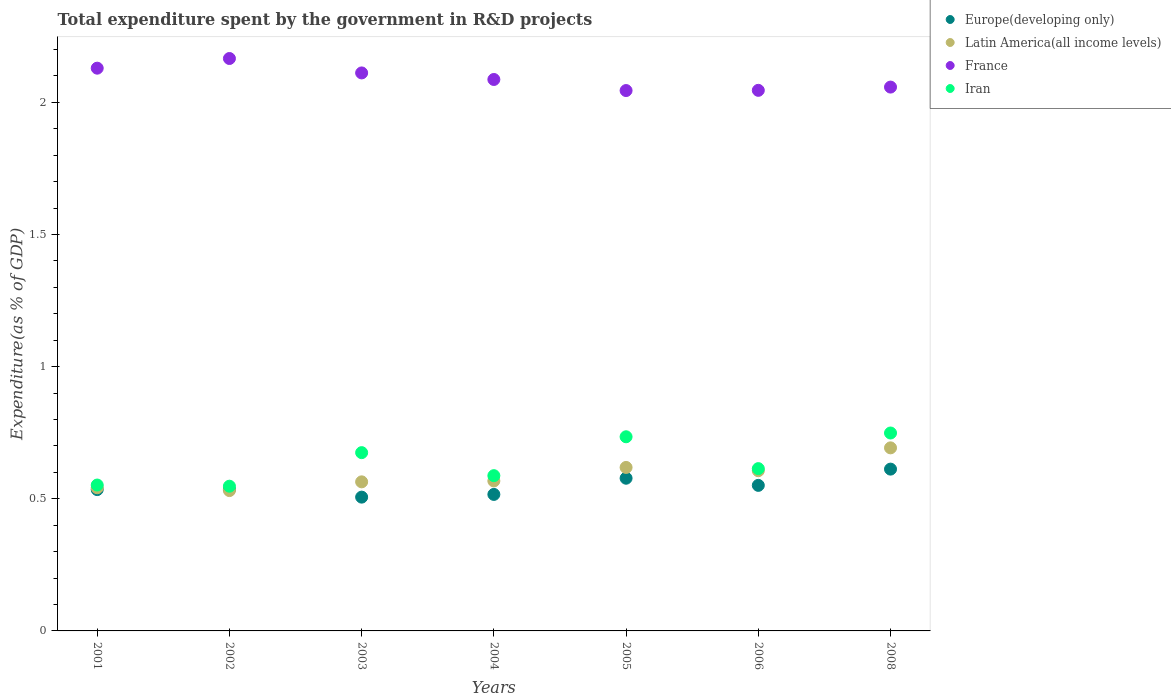What is the total expenditure spent by the government in R&D projects in France in 2002?
Your answer should be compact. 2.17. Across all years, what is the maximum total expenditure spent by the government in R&D projects in Latin America(all income levels)?
Offer a very short reply. 0.69. Across all years, what is the minimum total expenditure spent by the government in R&D projects in France?
Keep it short and to the point. 2.04. In which year was the total expenditure spent by the government in R&D projects in France minimum?
Give a very brief answer. 2005. What is the total total expenditure spent by the government in R&D projects in Europe(developing only) in the graph?
Give a very brief answer. 3.83. What is the difference between the total expenditure spent by the government in R&D projects in Europe(developing only) in 2005 and that in 2008?
Offer a terse response. -0.03. What is the difference between the total expenditure spent by the government in R&D projects in Latin America(all income levels) in 2002 and the total expenditure spent by the government in R&D projects in France in 2001?
Make the answer very short. -1.6. What is the average total expenditure spent by the government in R&D projects in Europe(developing only) per year?
Give a very brief answer. 0.55. In the year 2006, what is the difference between the total expenditure spent by the government in R&D projects in Europe(developing only) and total expenditure spent by the government in R&D projects in Iran?
Make the answer very short. -0.06. In how many years, is the total expenditure spent by the government in R&D projects in Europe(developing only) greater than 0.30000000000000004 %?
Offer a terse response. 7. What is the ratio of the total expenditure spent by the government in R&D projects in Latin America(all income levels) in 2002 to that in 2004?
Offer a very short reply. 0.94. Is the difference between the total expenditure spent by the government in R&D projects in Europe(developing only) in 2001 and 2003 greater than the difference between the total expenditure spent by the government in R&D projects in Iran in 2001 and 2003?
Your answer should be very brief. Yes. What is the difference between the highest and the second highest total expenditure spent by the government in R&D projects in Europe(developing only)?
Your answer should be compact. 0.03. What is the difference between the highest and the lowest total expenditure spent by the government in R&D projects in Iran?
Your response must be concise. 0.2. In how many years, is the total expenditure spent by the government in R&D projects in France greater than the average total expenditure spent by the government in R&D projects in France taken over all years?
Give a very brief answer. 3. Is it the case that in every year, the sum of the total expenditure spent by the government in R&D projects in France and total expenditure spent by the government in R&D projects in Iran  is greater than the sum of total expenditure spent by the government in R&D projects in Latin America(all income levels) and total expenditure spent by the government in R&D projects in Europe(developing only)?
Your response must be concise. Yes. Does the total expenditure spent by the government in R&D projects in Latin America(all income levels) monotonically increase over the years?
Your answer should be very brief. No. Is the total expenditure spent by the government in R&D projects in France strictly greater than the total expenditure spent by the government in R&D projects in Iran over the years?
Offer a terse response. Yes. Is the total expenditure spent by the government in R&D projects in Iran strictly less than the total expenditure spent by the government in R&D projects in France over the years?
Give a very brief answer. Yes. How many dotlines are there?
Keep it short and to the point. 4. How many years are there in the graph?
Give a very brief answer. 7. What is the difference between two consecutive major ticks on the Y-axis?
Ensure brevity in your answer.  0.5. Does the graph contain grids?
Make the answer very short. No. Where does the legend appear in the graph?
Give a very brief answer. Top right. How many legend labels are there?
Provide a succinct answer. 4. What is the title of the graph?
Ensure brevity in your answer.  Total expenditure spent by the government in R&D projects. Does "Mongolia" appear as one of the legend labels in the graph?
Give a very brief answer. No. What is the label or title of the Y-axis?
Your answer should be very brief. Expenditure(as % of GDP). What is the Expenditure(as % of GDP) in Europe(developing only) in 2001?
Your answer should be compact. 0.53. What is the Expenditure(as % of GDP) in Latin America(all income levels) in 2001?
Make the answer very short. 0.54. What is the Expenditure(as % of GDP) of France in 2001?
Provide a short and direct response. 2.13. What is the Expenditure(as % of GDP) in Iran in 2001?
Make the answer very short. 0.55. What is the Expenditure(as % of GDP) of Europe(developing only) in 2002?
Provide a short and direct response. 0.54. What is the Expenditure(as % of GDP) of Latin America(all income levels) in 2002?
Your response must be concise. 0.53. What is the Expenditure(as % of GDP) in France in 2002?
Keep it short and to the point. 2.17. What is the Expenditure(as % of GDP) in Iran in 2002?
Give a very brief answer. 0.55. What is the Expenditure(as % of GDP) in Europe(developing only) in 2003?
Make the answer very short. 0.51. What is the Expenditure(as % of GDP) in Latin America(all income levels) in 2003?
Your response must be concise. 0.56. What is the Expenditure(as % of GDP) of France in 2003?
Make the answer very short. 2.11. What is the Expenditure(as % of GDP) in Iran in 2003?
Give a very brief answer. 0.67. What is the Expenditure(as % of GDP) in Europe(developing only) in 2004?
Provide a short and direct response. 0.52. What is the Expenditure(as % of GDP) of Latin America(all income levels) in 2004?
Your response must be concise. 0.57. What is the Expenditure(as % of GDP) of France in 2004?
Provide a short and direct response. 2.09. What is the Expenditure(as % of GDP) in Iran in 2004?
Provide a succinct answer. 0.59. What is the Expenditure(as % of GDP) of Europe(developing only) in 2005?
Provide a succinct answer. 0.58. What is the Expenditure(as % of GDP) of Latin America(all income levels) in 2005?
Your response must be concise. 0.62. What is the Expenditure(as % of GDP) in France in 2005?
Ensure brevity in your answer.  2.04. What is the Expenditure(as % of GDP) in Iran in 2005?
Your response must be concise. 0.73. What is the Expenditure(as % of GDP) of Europe(developing only) in 2006?
Offer a terse response. 0.55. What is the Expenditure(as % of GDP) in Latin America(all income levels) in 2006?
Your answer should be very brief. 0.61. What is the Expenditure(as % of GDP) of France in 2006?
Provide a short and direct response. 2.05. What is the Expenditure(as % of GDP) of Iran in 2006?
Ensure brevity in your answer.  0.61. What is the Expenditure(as % of GDP) of Europe(developing only) in 2008?
Your response must be concise. 0.61. What is the Expenditure(as % of GDP) in Latin America(all income levels) in 2008?
Provide a succinct answer. 0.69. What is the Expenditure(as % of GDP) in France in 2008?
Your answer should be compact. 2.06. What is the Expenditure(as % of GDP) in Iran in 2008?
Your answer should be very brief. 0.75. Across all years, what is the maximum Expenditure(as % of GDP) of Europe(developing only)?
Your response must be concise. 0.61. Across all years, what is the maximum Expenditure(as % of GDP) of Latin America(all income levels)?
Your answer should be compact. 0.69. Across all years, what is the maximum Expenditure(as % of GDP) in France?
Provide a succinct answer. 2.17. Across all years, what is the maximum Expenditure(as % of GDP) of Iran?
Your answer should be compact. 0.75. Across all years, what is the minimum Expenditure(as % of GDP) of Europe(developing only)?
Your answer should be very brief. 0.51. Across all years, what is the minimum Expenditure(as % of GDP) in Latin America(all income levels)?
Your answer should be very brief. 0.53. Across all years, what is the minimum Expenditure(as % of GDP) of France?
Keep it short and to the point. 2.04. Across all years, what is the minimum Expenditure(as % of GDP) in Iran?
Ensure brevity in your answer.  0.55. What is the total Expenditure(as % of GDP) of Europe(developing only) in the graph?
Provide a short and direct response. 3.83. What is the total Expenditure(as % of GDP) of Latin America(all income levels) in the graph?
Your response must be concise. 4.12. What is the total Expenditure(as % of GDP) of France in the graph?
Offer a very short reply. 14.64. What is the total Expenditure(as % of GDP) in Iran in the graph?
Keep it short and to the point. 4.46. What is the difference between the Expenditure(as % of GDP) of Europe(developing only) in 2001 and that in 2002?
Provide a succinct answer. -0. What is the difference between the Expenditure(as % of GDP) of Latin America(all income levels) in 2001 and that in 2002?
Ensure brevity in your answer.  0.01. What is the difference between the Expenditure(as % of GDP) of France in 2001 and that in 2002?
Keep it short and to the point. -0.04. What is the difference between the Expenditure(as % of GDP) in Iran in 2001 and that in 2002?
Ensure brevity in your answer.  0. What is the difference between the Expenditure(as % of GDP) in Europe(developing only) in 2001 and that in 2003?
Offer a terse response. 0.03. What is the difference between the Expenditure(as % of GDP) in Latin America(all income levels) in 2001 and that in 2003?
Your response must be concise. -0.02. What is the difference between the Expenditure(as % of GDP) of France in 2001 and that in 2003?
Give a very brief answer. 0.02. What is the difference between the Expenditure(as % of GDP) of Iran in 2001 and that in 2003?
Your answer should be compact. -0.12. What is the difference between the Expenditure(as % of GDP) of Europe(developing only) in 2001 and that in 2004?
Offer a terse response. 0.02. What is the difference between the Expenditure(as % of GDP) of Latin America(all income levels) in 2001 and that in 2004?
Offer a very short reply. -0.03. What is the difference between the Expenditure(as % of GDP) in France in 2001 and that in 2004?
Keep it short and to the point. 0.04. What is the difference between the Expenditure(as % of GDP) of Iran in 2001 and that in 2004?
Provide a succinct answer. -0.04. What is the difference between the Expenditure(as % of GDP) of Europe(developing only) in 2001 and that in 2005?
Offer a terse response. -0.04. What is the difference between the Expenditure(as % of GDP) of Latin America(all income levels) in 2001 and that in 2005?
Make the answer very short. -0.08. What is the difference between the Expenditure(as % of GDP) in France in 2001 and that in 2005?
Keep it short and to the point. 0.08. What is the difference between the Expenditure(as % of GDP) of Iran in 2001 and that in 2005?
Ensure brevity in your answer.  -0.18. What is the difference between the Expenditure(as % of GDP) in Europe(developing only) in 2001 and that in 2006?
Offer a terse response. -0.02. What is the difference between the Expenditure(as % of GDP) in Latin America(all income levels) in 2001 and that in 2006?
Your answer should be compact. -0.06. What is the difference between the Expenditure(as % of GDP) of France in 2001 and that in 2006?
Make the answer very short. 0.08. What is the difference between the Expenditure(as % of GDP) of Iran in 2001 and that in 2006?
Your answer should be compact. -0.06. What is the difference between the Expenditure(as % of GDP) of Europe(developing only) in 2001 and that in 2008?
Your answer should be compact. -0.08. What is the difference between the Expenditure(as % of GDP) in Latin America(all income levels) in 2001 and that in 2008?
Your answer should be compact. -0.15. What is the difference between the Expenditure(as % of GDP) in France in 2001 and that in 2008?
Your response must be concise. 0.07. What is the difference between the Expenditure(as % of GDP) in Iran in 2001 and that in 2008?
Make the answer very short. -0.2. What is the difference between the Expenditure(as % of GDP) of Europe(developing only) in 2002 and that in 2003?
Offer a terse response. 0.03. What is the difference between the Expenditure(as % of GDP) of Latin America(all income levels) in 2002 and that in 2003?
Ensure brevity in your answer.  -0.03. What is the difference between the Expenditure(as % of GDP) in France in 2002 and that in 2003?
Make the answer very short. 0.05. What is the difference between the Expenditure(as % of GDP) of Iran in 2002 and that in 2003?
Give a very brief answer. -0.13. What is the difference between the Expenditure(as % of GDP) of Europe(developing only) in 2002 and that in 2004?
Your answer should be very brief. 0.02. What is the difference between the Expenditure(as % of GDP) in Latin America(all income levels) in 2002 and that in 2004?
Your answer should be very brief. -0.04. What is the difference between the Expenditure(as % of GDP) in France in 2002 and that in 2004?
Provide a short and direct response. 0.08. What is the difference between the Expenditure(as % of GDP) in Iran in 2002 and that in 2004?
Make the answer very short. -0.04. What is the difference between the Expenditure(as % of GDP) in Europe(developing only) in 2002 and that in 2005?
Ensure brevity in your answer.  -0.04. What is the difference between the Expenditure(as % of GDP) in Latin America(all income levels) in 2002 and that in 2005?
Your answer should be compact. -0.09. What is the difference between the Expenditure(as % of GDP) in France in 2002 and that in 2005?
Your answer should be compact. 0.12. What is the difference between the Expenditure(as % of GDP) of Iran in 2002 and that in 2005?
Give a very brief answer. -0.19. What is the difference between the Expenditure(as % of GDP) in Europe(developing only) in 2002 and that in 2006?
Give a very brief answer. -0.02. What is the difference between the Expenditure(as % of GDP) in Latin America(all income levels) in 2002 and that in 2006?
Your answer should be very brief. -0.08. What is the difference between the Expenditure(as % of GDP) in France in 2002 and that in 2006?
Offer a terse response. 0.12. What is the difference between the Expenditure(as % of GDP) of Iran in 2002 and that in 2006?
Keep it short and to the point. -0.07. What is the difference between the Expenditure(as % of GDP) in Europe(developing only) in 2002 and that in 2008?
Your answer should be compact. -0.08. What is the difference between the Expenditure(as % of GDP) of Latin America(all income levels) in 2002 and that in 2008?
Make the answer very short. -0.16. What is the difference between the Expenditure(as % of GDP) in France in 2002 and that in 2008?
Provide a short and direct response. 0.11. What is the difference between the Expenditure(as % of GDP) of Iran in 2002 and that in 2008?
Provide a short and direct response. -0.2. What is the difference between the Expenditure(as % of GDP) in Europe(developing only) in 2003 and that in 2004?
Your response must be concise. -0.01. What is the difference between the Expenditure(as % of GDP) in Latin America(all income levels) in 2003 and that in 2004?
Your answer should be very brief. -0. What is the difference between the Expenditure(as % of GDP) of France in 2003 and that in 2004?
Provide a succinct answer. 0.02. What is the difference between the Expenditure(as % of GDP) of Iran in 2003 and that in 2004?
Your response must be concise. 0.09. What is the difference between the Expenditure(as % of GDP) of Europe(developing only) in 2003 and that in 2005?
Your response must be concise. -0.07. What is the difference between the Expenditure(as % of GDP) in Latin America(all income levels) in 2003 and that in 2005?
Your answer should be very brief. -0.05. What is the difference between the Expenditure(as % of GDP) of France in 2003 and that in 2005?
Offer a terse response. 0.07. What is the difference between the Expenditure(as % of GDP) in Iran in 2003 and that in 2005?
Make the answer very short. -0.06. What is the difference between the Expenditure(as % of GDP) in Europe(developing only) in 2003 and that in 2006?
Your answer should be very brief. -0.04. What is the difference between the Expenditure(as % of GDP) in Latin America(all income levels) in 2003 and that in 2006?
Your answer should be compact. -0.04. What is the difference between the Expenditure(as % of GDP) in France in 2003 and that in 2006?
Offer a very short reply. 0.07. What is the difference between the Expenditure(as % of GDP) of Iran in 2003 and that in 2006?
Offer a very short reply. 0.06. What is the difference between the Expenditure(as % of GDP) in Europe(developing only) in 2003 and that in 2008?
Offer a terse response. -0.11. What is the difference between the Expenditure(as % of GDP) in Latin America(all income levels) in 2003 and that in 2008?
Your response must be concise. -0.13. What is the difference between the Expenditure(as % of GDP) in France in 2003 and that in 2008?
Provide a short and direct response. 0.05. What is the difference between the Expenditure(as % of GDP) of Iran in 2003 and that in 2008?
Provide a succinct answer. -0.07. What is the difference between the Expenditure(as % of GDP) of Europe(developing only) in 2004 and that in 2005?
Give a very brief answer. -0.06. What is the difference between the Expenditure(as % of GDP) in Latin America(all income levels) in 2004 and that in 2005?
Your answer should be compact. -0.05. What is the difference between the Expenditure(as % of GDP) of France in 2004 and that in 2005?
Your response must be concise. 0.04. What is the difference between the Expenditure(as % of GDP) of Iran in 2004 and that in 2005?
Offer a terse response. -0.15. What is the difference between the Expenditure(as % of GDP) in Europe(developing only) in 2004 and that in 2006?
Your answer should be very brief. -0.03. What is the difference between the Expenditure(as % of GDP) in Latin America(all income levels) in 2004 and that in 2006?
Give a very brief answer. -0.04. What is the difference between the Expenditure(as % of GDP) of France in 2004 and that in 2006?
Ensure brevity in your answer.  0.04. What is the difference between the Expenditure(as % of GDP) of Iran in 2004 and that in 2006?
Provide a succinct answer. -0.03. What is the difference between the Expenditure(as % of GDP) in Europe(developing only) in 2004 and that in 2008?
Provide a succinct answer. -0.1. What is the difference between the Expenditure(as % of GDP) of Latin America(all income levels) in 2004 and that in 2008?
Provide a short and direct response. -0.13. What is the difference between the Expenditure(as % of GDP) of France in 2004 and that in 2008?
Offer a very short reply. 0.03. What is the difference between the Expenditure(as % of GDP) of Iran in 2004 and that in 2008?
Keep it short and to the point. -0.16. What is the difference between the Expenditure(as % of GDP) of Europe(developing only) in 2005 and that in 2006?
Your answer should be compact. 0.03. What is the difference between the Expenditure(as % of GDP) of Latin America(all income levels) in 2005 and that in 2006?
Your response must be concise. 0.01. What is the difference between the Expenditure(as % of GDP) in France in 2005 and that in 2006?
Offer a very short reply. -0. What is the difference between the Expenditure(as % of GDP) of Iran in 2005 and that in 2006?
Make the answer very short. 0.12. What is the difference between the Expenditure(as % of GDP) in Europe(developing only) in 2005 and that in 2008?
Offer a terse response. -0.03. What is the difference between the Expenditure(as % of GDP) of Latin America(all income levels) in 2005 and that in 2008?
Your answer should be compact. -0.07. What is the difference between the Expenditure(as % of GDP) of France in 2005 and that in 2008?
Your response must be concise. -0.01. What is the difference between the Expenditure(as % of GDP) of Iran in 2005 and that in 2008?
Your answer should be compact. -0.01. What is the difference between the Expenditure(as % of GDP) in Europe(developing only) in 2006 and that in 2008?
Your answer should be very brief. -0.06. What is the difference between the Expenditure(as % of GDP) in Latin America(all income levels) in 2006 and that in 2008?
Provide a succinct answer. -0.09. What is the difference between the Expenditure(as % of GDP) in France in 2006 and that in 2008?
Give a very brief answer. -0.01. What is the difference between the Expenditure(as % of GDP) of Iran in 2006 and that in 2008?
Offer a terse response. -0.13. What is the difference between the Expenditure(as % of GDP) of Europe(developing only) in 2001 and the Expenditure(as % of GDP) of Latin America(all income levels) in 2002?
Offer a terse response. 0. What is the difference between the Expenditure(as % of GDP) in Europe(developing only) in 2001 and the Expenditure(as % of GDP) in France in 2002?
Your answer should be very brief. -1.63. What is the difference between the Expenditure(as % of GDP) of Europe(developing only) in 2001 and the Expenditure(as % of GDP) of Iran in 2002?
Offer a very short reply. -0.01. What is the difference between the Expenditure(as % of GDP) of Latin America(all income levels) in 2001 and the Expenditure(as % of GDP) of France in 2002?
Your response must be concise. -1.62. What is the difference between the Expenditure(as % of GDP) in Latin America(all income levels) in 2001 and the Expenditure(as % of GDP) in Iran in 2002?
Keep it short and to the point. -0.01. What is the difference between the Expenditure(as % of GDP) of France in 2001 and the Expenditure(as % of GDP) of Iran in 2002?
Give a very brief answer. 1.58. What is the difference between the Expenditure(as % of GDP) in Europe(developing only) in 2001 and the Expenditure(as % of GDP) in Latin America(all income levels) in 2003?
Your response must be concise. -0.03. What is the difference between the Expenditure(as % of GDP) of Europe(developing only) in 2001 and the Expenditure(as % of GDP) of France in 2003?
Keep it short and to the point. -1.58. What is the difference between the Expenditure(as % of GDP) of Europe(developing only) in 2001 and the Expenditure(as % of GDP) of Iran in 2003?
Your answer should be very brief. -0.14. What is the difference between the Expenditure(as % of GDP) in Latin America(all income levels) in 2001 and the Expenditure(as % of GDP) in France in 2003?
Provide a short and direct response. -1.57. What is the difference between the Expenditure(as % of GDP) in Latin America(all income levels) in 2001 and the Expenditure(as % of GDP) in Iran in 2003?
Your answer should be very brief. -0.13. What is the difference between the Expenditure(as % of GDP) in France in 2001 and the Expenditure(as % of GDP) in Iran in 2003?
Ensure brevity in your answer.  1.45. What is the difference between the Expenditure(as % of GDP) in Europe(developing only) in 2001 and the Expenditure(as % of GDP) in Latin America(all income levels) in 2004?
Provide a short and direct response. -0.03. What is the difference between the Expenditure(as % of GDP) in Europe(developing only) in 2001 and the Expenditure(as % of GDP) in France in 2004?
Your answer should be very brief. -1.55. What is the difference between the Expenditure(as % of GDP) of Europe(developing only) in 2001 and the Expenditure(as % of GDP) of Iran in 2004?
Keep it short and to the point. -0.05. What is the difference between the Expenditure(as % of GDP) of Latin America(all income levels) in 2001 and the Expenditure(as % of GDP) of France in 2004?
Make the answer very short. -1.54. What is the difference between the Expenditure(as % of GDP) of Latin America(all income levels) in 2001 and the Expenditure(as % of GDP) of Iran in 2004?
Make the answer very short. -0.05. What is the difference between the Expenditure(as % of GDP) of France in 2001 and the Expenditure(as % of GDP) of Iran in 2004?
Provide a short and direct response. 1.54. What is the difference between the Expenditure(as % of GDP) of Europe(developing only) in 2001 and the Expenditure(as % of GDP) of Latin America(all income levels) in 2005?
Offer a very short reply. -0.08. What is the difference between the Expenditure(as % of GDP) of Europe(developing only) in 2001 and the Expenditure(as % of GDP) of France in 2005?
Your answer should be compact. -1.51. What is the difference between the Expenditure(as % of GDP) in Europe(developing only) in 2001 and the Expenditure(as % of GDP) in Iran in 2005?
Offer a terse response. -0.2. What is the difference between the Expenditure(as % of GDP) in Latin America(all income levels) in 2001 and the Expenditure(as % of GDP) in France in 2005?
Provide a succinct answer. -1.5. What is the difference between the Expenditure(as % of GDP) of Latin America(all income levels) in 2001 and the Expenditure(as % of GDP) of Iran in 2005?
Give a very brief answer. -0.19. What is the difference between the Expenditure(as % of GDP) in France in 2001 and the Expenditure(as % of GDP) in Iran in 2005?
Provide a succinct answer. 1.39. What is the difference between the Expenditure(as % of GDP) of Europe(developing only) in 2001 and the Expenditure(as % of GDP) of Latin America(all income levels) in 2006?
Make the answer very short. -0.07. What is the difference between the Expenditure(as % of GDP) in Europe(developing only) in 2001 and the Expenditure(as % of GDP) in France in 2006?
Your answer should be compact. -1.51. What is the difference between the Expenditure(as % of GDP) in Europe(developing only) in 2001 and the Expenditure(as % of GDP) in Iran in 2006?
Your answer should be compact. -0.08. What is the difference between the Expenditure(as % of GDP) in Latin America(all income levels) in 2001 and the Expenditure(as % of GDP) in France in 2006?
Your response must be concise. -1.5. What is the difference between the Expenditure(as % of GDP) in Latin America(all income levels) in 2001 and the Expenditure(as % of GDP) in Iran in 2006?
Keep it short and to the point. -0.07. What is the difference between the Expenditure(as % of GDP) of France in 2001 and the Expenditure(as % of GDP) of Iran in 2006?
Offer a very short reply. 1.52. What is the difference between the Expenditure(as % of GDP) in Europe(developing only) in 2001 and the Expenditure(as % of GDP) in Latin America(all income levels) in 2008?
Provide a succinct answer. -0.16. What is the difference between the Expenditure(as % of GDP) of Europe(developing only) in 2001 and the Expenditure(as % of GDP) of France in 2008?
Your response must be concise. -1.52. What is the difference between the Expenditure(as % of GDP) in Europe(developing only) in 2001 and the Expenditure(as % of GDP) in Iran in 2008?
Offer a terse response. -0.21. What is the difference between the Expenditure(as % of GDP) in Latin America(all income levels) in 2001 and the Expenditure(as % of GDP) in France in 2008?
Ensure brevity in your answer.  -1.52. What is the difference between the Expenditure(as % of GDP) of Latin America(all income levels) in 2001 and the Expenditure(as % of GDP) of Iran in 2008?
Your answer should be compact. -0.21. What is the difference between the Expenditure(as % of GDP) in France in 2001 and the Expenditure(as % of GDP) in Iran in 2008?
Provide a short and direct response. 1.38. What is the difference between the Expenditure(as % of GDP) of Europe(developing only) in 2002 and the Expenditure(as % of GDP) of Latin America(all income levels) in 2003?
Your response must be concise. -0.03. What is the difference between the Expenditure(as % of GDP) in Europe(developing only) in 2002 and the Expenditure(as % of GDP) in France in 2003?
Your response must be concise. -1.58. What is the difference between the Expenditure(as % of GDP) of Europe(developing only) in 2002 and the Expenditure(as % of GDP) of Iran in 2003?
Make the answer very short. -0.14. What is the difference between the Expenditure(as % of GDP) in Latin America(all income levels) in 2002 and the Expenditure(as % of GDP) in France in 2003?
Provide a succinct answer. -1.58. What is the difference between the Expenditure(as % of GDP) in Latin America(all income levels) in 2002 and the Expenditure(as % of GDP) in Iran in 2003?
Provide a succinct answer. -0.14. What is the difference between the Expenditure(as % of GDP) of France in 2002 and the Expenditure(as % of GDP) of Iran in 2003?
Provide a succinct answer. 1.49. What is the difference between the Expenditure(as % of GDP) in Europe(developing only) in 2002 and the Expenditure(as % of GDP) in Latin America(all income levels) in 2004?
Your answer should be very brief. -0.03. What is the difference between the Expenditure(as % of GDP) of Europe(developing only) in 2002 and the Expenditure(as % of GDP) of France in 2004?
Make the answer very short. -1.55. What is the difference between the Expenditure(as % of GDP) in Europe(developing only) in 2002 and the Expenditure(as % of GDP) in Iran in 2004?
Keep it short and to the point. -0.05. What is the difference between the Expenditure(as % of GDP) in Latin America(all income levels) in 2002 and the Expenditure(as % of GDP) in France in 2004?
Your answer should be compact. -1.56. What is the difference between the Expenditure(as % of GDP) of Latin America(all income levels) in 2002 and the Expenditure(as % of GDP) of Iran in 2004?
Your response must be concise. -0.06. What is the difference between the Expenditure(as % of GDP) of France in 2002 and the Expenditure(as % of GDP) of Iran in 2004?
Your response must be concise. 1.58. What is the difference between the Expenditure(as % of GDP) in Europe(developing only) in 2002 and the Expenditure(as % of GDP) in Latin America(all income levels) in 2005?
Your answer should be compact. -0.08. What is the difference between the Expenditure(as % of GDP) in Europe(developing only) in 2002 and the Expenditure(as % of GDP) in France in 2005?
Provide a short and direct response. -1.51. What is the difference between the Expenditure(as % of GDP) of Europe(developing only) in 2002 and the Expenditure(as % of GDP) of Iran in 2005?
Your answer should be compact. -0.2. What is the difference between the Expenditure(as % of GDP) in Latin America(all income levels) in 2002 and the Expenditure(as % of GDP) in France in 2005?
Ensure brevity in your answer.  -1.51. What is the difference between the Expenditure(as % of GDP) in Latin America(all income levels) in 2002 and the Expenditure(as % of GDP) in Iran in 2005?
Keep it short and to the point. -0.2. What is the difference between the Expenditure(as % of GDP) of France in 2002 and the Expenditure(as % of GDP) of Iran in 2005?
Your response must be concise. 1.43. What is the difference between the Expenditure(as % of GDP) of Europe(developing only) in 2002 and the Expenditure(as % of GDP) of Latin America(all income levels) in 2006?
Offer a very short reply. -0.07. What is the difference between the Expenditure(as % of GDP) in Europe(developing only) in 2002 and the Expenditure(as % of GDP) in France in 2006?
Make the answer very short. -1.51. What is the difference between the Expenditure(as % of GDP) of Europe(developing only) in 2002 and the Expenditure(as % of GDP) of Iran in 2006?
Make the answer very short. -0.08. What is the difference between the Expenditure(as % of GDP) in Latin America(all income levels) in 2002 and the Expenditure(as % of GDP) in France in 2006?
Give a very brief answer. -1.51. What is the difference between the Expenditure(as % of GDP) of Latin America(all income levels) in 2002 and the Expenditure(as % of GDP) of Iran in 2006?
Offer a very short reply. -0.08. What is the difference between the Expenditure(as % of GDP) in France in 2002 and the Expenditure(as % of GDP) in Iran in 2006?
Ensure brevity in your answer.  1.55. What is the difference between the Expenditure(as % of GDP) of Europe(developing only) in 2002 and the Expenditure(as % of GDP) of Latin America(all income levels) in 2008?
Provide a short and direct response. -0.16. What is the difference between the Expenditure(as % of GDP) of Europe(developing only) in 2002 and the Expenditure(as % of GDP) of France in 2008?
Offer a very short reply. -1.52. What is the difference between the Expenditure(as % of GDP) in Europe(developing only) in 2002 and the Expenditure(as % of GDP) in Iran in 2008?
Your answer should be very brief. -0.21. What is the difference between the Expenditure(as % of GDP) in Latin America(all income levels) in 2002 and the Expenditure(as % of GDP) in France in 2008?
Make the answer very short. -1.53. What is the difference between the Expenditure(as % of GDP) of Latin America(all income levels) in 2002 and the Expenditure(as % of GDP) of Iran in 2008?
Offer a terse response. -0.22. What is the difference between the Expenditure(as % of GDP) of France in 2002 and the Expenditure(as % of GDP) of Iran in 2008?
Provide a short and direct response. 1.42. What is the difference between the Expenditure(as % of GDP) in Europe(developing only) in 2003 and the Expenditure(as % of GDP) in Latin America(all income levels) in 2004?
Your answer should be compact. -0.06. What is the difference between the Expenditure(as % of GDP) of Europe(developing only) in 2003 and the Expenditure(as % of GDP) of France in 2004?
Your answer should be compact. -1.58. What is the difference between the Expenditure(as % of GDP) in Europe(developing only) in 2003 and the Expenditure(as % of GDP) in Iran in 2004?
Your response must be concise. -0.08. What is the difference between the Expenditure(as % of GDP) of Latin America(all income levels) in 2003 and the Expenditure(as % of GDP) of France in 2004?
Give a very brief answer. -1.52. What is the difference between the Expenditure(as % of GDP) in Latin America(all income levels) in 2003 and the Expenditure(as % of GDP) in Iran in 2004?
Offer a very short reply. -0.02. What is the difference between the Expenditure(as % of GDP) in France in 2003 and the Expenditure(as % of GDP) in Iran in 2004?
Offer a very short reply. 1.52. What is the difference between the Expenditure(as % of GDP) in Europe(developing only) in 2003 and the Expenditure(as % of GDP) in Latin America(all income levels) in 2005?
Your answer should be very brief. -0.11. What is the difference between the Expenditure(as % of GDP) in Europe(developing only) in 2003 and the Expenditure(as % of GDP) in France in 2005?
Give a very brief answer. -1.54. What is the difference between the Expenditure(as % of GDP) of Europe(developing only) in 2003 and the Expenditure(as % of GDP) of Iran in 2005?
Provide a short and direct response. -0.23. What is the difference between the Expenditure(as % of GDP) of Latin America(all income levels) in 2003 and the Expenditure(as % of GDP) of France in 2005?
Offer a very short reply. -1.48. What is the difference between the Expenditure(as % of GDP) in Latin America(all income levels) in 2003 and the Expenditure(as % of GDP) in Iran in 2005?
Your answer should be very brief. -0.17. What is the difference between the Expenditure(as % of GDP) of France in 2003 and the Expenditure(as % of GDP) of Iran in 2005?
Provide a short and direct response. 1.38. What is the difference between the Expenditure(as % of GDP) in Europe(developing only) in 2003 and the Expenditure(as % of GDP) in Latin America(all income levels) in 2006?
Provide a short and direct response. -0.1. What is the difference between the Expenditure(as % of GDP) of Europe(developing only) in 2003 and the Expenditure(as % of GDP) of France in 2006?
Provide a short and direct response. -1.54. What is the difference between the Expenditure(as % of GDP) of Europe(developing only) in 2003 and the Expenditure(as % of GDP) of Iran in 2006?
Offer a terse response. -0.11. What is the difference between the Expenditure(as % of GDP) of Latin America(all income levels) in 2003 and the Expenditure(as % of GDP) of France in 2006?
Give a very brief answer. -1.48. What is the difference between the Expenditure(as % of GDP) in France in 2003 and the Expenditure(as % of GDP) in Iran in 2006?
Provide a short and direct response. 1.5. What is the difference between the Expenditure(as % of GDP) of Europe(developing only) in 2003 and the Expenditure(as % of GDP) of Latin America(all income levels) in 2008?
Your response must be concise. -0.19. What is the difference between the Expenditure(as % of GDP) of Europe(developing only) in 2003 and the Expenditure(as % of GDP) of France in 2008?
Ensure brevity in your answer.  -1.55. What is the difference between the Expenditure(as % of GDP) of Europe(developing only) in 2003 and the Expenditure(as % of GDP) of Iran in 2008?
Your answer should be compact. -0.24. What is the difference between the Expenditure(as % of GDP) of Latin America(all income levels) in 2003 and the Expenditure(as % of GDP) of France in 2008?
Offer a very short reply. -1.49. What is the difference between the Expenditure(as % of GDP) of Latin America(all income levels) in 2003 and the Expenditure(as % of GDP) of Iran in 2008?
Your answer should be very brief. -0.18. What is the difference between the Expenditure(as % of GDP) of France in 2003 and the Expenditure(as % of GDP) of Iran in 2008?
Give a very brief answer. 1.36. What is the difference between the Expenditure(as % of GDP) of Europe(developing only) in 2004 and the Expenditure(as % of GDP) of Latin America(all income levels) in 2005?
Make the answer very short. -0.1. What is the difference between the Expenditure(as % of GDP) in Europe(developing only) in 2004 and the Expenditure(as % of GDP) in France in 2005?
Provide a succinct answer. -1.53. What is the difference between the Expenditure(as % of GDP) of Europe(developing only) in 2004 and the Expenditure(as % of GDP) of Iran in 2005?
Provide a succinct answer. -0.22. What is the difference between the Expenditure(as % of GDP) in Latin America(all income levels) in 2004 and the Expenditure(as % of GDP) in France in 2005?
Offer a terse response. -1.48. What is the difference between the Expenditure(as % of GDP) in Latin America(all income levels) in 2004 and the Expenditure(as % of GDP) in Iran in 2005?
Offer a terse response. -0.17. What is the difference between the Expenditure(as % of GDP) of France in 2004 and the Expenditure(as % of GDP) of Iran in 2005?
Your answer should be very brief. 1.35. What is the difference between the Expenditure(as % of GDP) of Europe(developing only) in 2004 and the Expenditure(as % of GDP) of Latin America(all income levels) in 2006?
Ensure brevity in your answer.  -0.09. What is the difference between the Expenditure(as % of GDP) of Europe(developing only) in 2004 and the Expenditure(as % of GDP) of France in 2006?
Give a very brief answer. -1.53. What is the difference between the Expenditure(as % of GDP) in Europe(developing only) in 2004 and the Expenditure(as % of GDP) in Iran in 2006?
Offer a very short reply. -0.1. What is the difference between the Expenditure(as % of GDP) of Latin America(all income levels) in 2004 and the Expenditure(as % of GDP) of France in 2006?
Give a very brief answer. -1.48. What is the difference between the Expenditure(as % of GDP) in Latin America(all income levels) in 2004 and the Expenditure(as % of GDP) in Iran in 2006?
Provide a succinct answer. -0.05. What is the difference between the Expenditure(as % of GDP) of France in 2004 and the Expenditure(as % of GDP) of Iran in 2006?
Provide a succinct answer. 1.47. What is the difference between the Expenditure(as % of GDP) of Europe(developing only) in 2004 and the Expenditure(as % of GDP) of Latin America(all income levels) in 2008?
Offer a terse response. -0.18. What is the difference between the Expenditure(as % of GDP) in Europe(developing only) in 2004 and the Expenditure(as % of GDP) in France in 2008?
Your response must be concise. -1.54. What is the difference between the Expenditure(as % of GDP) of Europe(developing only) in 2004 and the Expenditure(as % of GDP) of Iran in 2008?
Make the answer very short. -0.23. What is the difference between the Expenditure(as % of GDP) in Latin America(all income levels) in 2004 and the Expenditure(as % of GDP) in France in 2008?
Give a very brief answer. -1.49. What is the difference between the Expenditure(as % of GDP) in Latin America(all income levels) in 2004 and the Expenditure(as % of GDP) in Iran in 2008?
Give a very brief answer. -0.18. What is the difference between the Expenditure(as % of GDP) in France in 2004 and the Expenditure(as % of GDP) in Iran in 2008?
Keep it short and to the point. 1.34. What is the difference between the Expenditure(as % of GDP) of Europe(developing only) in 2005 and the Expenditure(as % of GDP) of Latin America(all income levels) in 2006?
Provide a short and direct response. -0.03. What is the difference between the Expenditure(as % of GDP) of Europe(developing only) in 2005 and the Expenditure(as % of GDP) of France in 2006?
Make the answer very short. -1.47. What is the difference between the Expenditure(as % of GDP) in Europe(developing only) in 2005 and the Expenditure(as % of GDP) in Iran in 2006?
Offer a very short reply. -0.04. What is the difference between the Expenditure(as % of GDP) in Latin America(all income levels) in 2005 and the Expenditure(as % of GDP) in France in 2006?
Provide a succinct answer. -1.43. What is the difference between the Expenditure(as % of GDP) of Latin America(all income levels) in 2005 and the Expenditure(as % of GDP) of Iran in 2006?
Offer a very short reply. 0. What is the difference between the Expenditure(as % of GDP) of France in 2005 and the Expenditure(as % of GDP) of Iran in 2006?
Offer a very short reply. 1.43. What is the difference between the Expenditure(as % of GDP) in Europe(developing only) in 2005 and the Expenditure(as % of GDP) in Latin America(all income levels) in 2008?
Make the answer very short. -0.11. What is the difference between the Expenditure(as % of GDP) in Europe(developing only) in 2005 and the Expenditure(as % of GDP) in France in 2008?
Offer a terse response. -1.48. What is the difference between the Expenditure(as % of GDP) in Europe(developing only) in 2005 and the Expenditure(as % of GDP) in Iran in 2008?
Make the answer very short. -0.17. What is the difference between the Expenditure(as % of GDP) in Latin America(all income levels) in 2005 and the Expenditure(as % of GDP) in France in 2008?
Make the answer very short. -1.44. What is the difference between the Expenditure(as % of GDP) of Latin America(all income levels) in 2005 and the Expenditure(as % of GDP) of Iran in 2008?
Keep it short and to the point. -0.13. What is the difference between the Expenditure(as % of GDP) in France in 2005 and the Expenditure(as % of GDP) in Iran in 2008?
Give a very brief answer. 1.3. What is the difference between the Expenditure(as % of GDP) in Europe(developing only) in 2006 and the Expenditure(as % of GDP) in Latin America(all income levels) in 2008?
Keep it short and to the point. -0.14. What is the difference between the Expenditure(as % of GDP) of Europe(developing only) in 2006 and the Expenditure(as % of GDP) of France in 2008?
Provide a short and direct response. -1.51. What is the difference between the Expenditure(as % of GDP) in Europe(developing only) in 2006 and the Expenditure(as % of GDP) in Iran in 2008?
Give a very brief answer. -0.2. What is the difference between the Expenditure(as % of GDP) of Latin America(all income levels) in 2006 and the Expenditure(as % of GDP) of France in 2008?
Keep it short and to the point. -1.45. What is the difference between the Expenditure(as % of GDP) of Latin America(all income levels) in 2006 and the Expenditure(as % of GDP) of Iran in 2008?
Make the answer very short. -0.14. What is the difference between the Expenditure(as % of GDP) of France in 2006 and the Expenditure(as % of GDP) of Iran in 2008?
Keep it short and to the point. 1.3. What is the average Expenditure(as % of GDP) in Europe(developing only) per year?
Your response must be concise. 0.55. What is the average Expenditure(as % of GDP) in Latin America(all income levels) per year?
Ensure brevity in your answer.  0.59. What is the average Expenditure(as % of GDP) in France per year?
Give a very brief answer. 2.09. What is the average Expenditure(as % of GDP) in Iran per year?
Your answer should be compact. 0.64. In the year 2001, what is the difference between the Expenditure(as % of GDP) of Europe(developing only) and Expenditure(as % of GDP) of Latin America(all income levels)?
Provide a short and direct response. -0.01. In the year 2001, what is the difference between the Expenditure(as % of GDP) in Europe(developing only) and Expenditure(as % of GDP) in France?
Your answer should be compact. -1.59. In the year 2001, what is the difference between the Expenditure(as % of GDP) of Europe(developing only) and Expenditure(as % of GDP) of Iran?
Provide a succinct answer. -0.02. In the year 2001, what is the difference between the Expenditure(as % of GDP) of Latin America(all income levels) and Expenditure(as % of GDP) of France?
Your answer should be compact. -1.59. In the year 2001, what is the difference between the Expenditure(as % of GDP) of Latin America(all income levels) and Expenditure(as % of GDP) of Iran?
Your response must be concise. -0.01. In the year 2001, what is the difference between the Expenditure(as % of GDP) in France and Expenditure(as % of GDP) in Iran?
Keep it short and to the point. 1.58. In the year 2002, what is the difference between the Expenditure(as % of GDP) in Europe(developing only) and Expenditure(as % of GDP) in Latin America(all income levels)?
Give a very brief answer. 0. In the year 2002, what is the difference between the Expenditure(as % of GDP) in Europe(developing only) and Expenditure(as % of GDP) in France?
Offer a very short reply. -1.63. In the year 2002, what is the difference between the Expenditure(as % of GDP) of Europe(developing only) and Expenditure(as % of GDP) of Iran?
Your response must be concise. -0.01. In the year 2002, what is the difference between the Expenditure(as % of GDP) of Latin America(all income levels) and Expenditure(as % of GDP) of France?
Offer a terse response. -1.63. In the year 2002, what is the difference between the Expenditure(as % of GDP) in Latin America(all income levels) and Expenditure(as % of GDP) in Iran?
Your response must be concise. -0.02. In the year 2002, what is the difference between the Expenditure(as % of GDP) of France and Expenditure(as % of GDP) of Iran?
Offer a terse response. 1.62. In the year 2003, what is the difference between the Expenditure(as % of GDP) in Europe(developing only) and Expenditure(as % of GDP) in Latin America(all income levels)?
Keep it short and to the point. -0.06. In the year 2003, what is the difference between the Expenditure(as % of GDP) in Europe(developing only) and Expenditure(as % of GDP) in France?
Your answer should be very brief. -1.6. In the year 2003, what is the difference between the Expenditure(as % of GDP) in Europe(developing only) and Expenditure(as % of GDP) in Iran?
Your answer should be very brief. -0.17. In the year 2003, what is the difference between the Expenditure(as % of GDP) in Latin America(all income levels) and Expenditure(as % of GDP) in France?
Offer a terse response. -1.55. In the year 2003, what is the difference between the Expenditure(as % of GDP) in Latin America(all income levels) and Expenditure(as % of GDP) in Iran?
Make the answer very short. -0.11. In the year 2003, what is the difference between the Expenditure(as % of GDP) in France and Expenditure(as % of GDP) in Iran?
Offer a terse response. 1.44. In the year 2004, what is the difference between the Expenditure(as % of GDP) in Europe(developing only) and Expenditure(as % of GDP) in Latin America(all income levels)?
Keep it short and to the point. -0.05. In the year 2004, what is the difference between the Expenditure(as % of GDP) of Europe(developing only) and Expenditure(as % of GDP) of France?
Offer a terse response. -1.57. In the year 2004, what is the difference between the Expenditure(as % of GDP) of Europe(developing only) and Expenditure(as % of GDP) of Iran?
Keep it short and to the point. -0.07. In the year 2004, what is the difference between the Expenditure(as % of GDP) of Latin America(all income levels) and Expenditure(as % of GDP) of France?
Ensure brevity in your answer.  -1.52. In the year 2004, what is the difference between the Expenditure(as % of GDP) in Latin America(all income levels) and Expenditure(as % of GDP) in Iran?
Your answer should be very brief. -0.02. In the year 2004, what is the difference between the Expenditure(as % of GDP) of France and Expenditure(as % of GDP) of Iran?
Your response must be concise. 1.5. In the year 2005, what is the difference between the Expenditure(as % of GDP) of Europe(developing only) and Expenditure(as % of GDP) of Latin America(all income levels)?
Offer a terse response. -0.04. In the year 2005, what is the difference between the Expenditure(as % of GDP) in Europe(developing only) and Expenditure(as % of GDP) in France?
Ensure brevity in your answer.  -1.47. In the year 2005, what is the difference between the Expenditure(as % of GDP) of Europe(developing only) and Expenditure(as % of GDP) of Iran?
Provide a succinct answer. -0.16. In the year 2005, what is the difference between the Expenditure(as % of GDP) of Latin America(all income levels) and Expenditure(as % of GDP) of France?
Make the answer very short. -1.43. In the year 2005, what is the difference between the Expenditure(as % of GDP) of Latin America(all income levels) and Expenditure(as % of GDP) of Iran?
Offer a very short reply. -0.12. In the year 2005, what is the difference between the Expenditure(as % of GDP) of France and Expenditure(as % of GDP) of Iran?
Your answer should be very brief. 1.31. In the year 2006, what is the difference between the Expenditure(as % of GDP) of Europe(developing only) and Expenditure(as % of GDP) of Latin America(all income levels)?
Give a very brief answer. -0.06. In the year 2006, what is the difference between the Expenditure(as % of GDP) in Europe(developing only) and Expenditure(as % of GDP) in France?
Give a very brief answer. -1.49. In the year 2006, what is the difference between the Expenditure(as % of GDP) in Europe(developing only) and Expenditure(as % of GDP) in Iran?
Make the answer very short. -0.06. In the year 2006, what is the difference between the Expenditure(as % of GDP) in Latin America(all income levels) and Expenditure(as % of GDP) in France?
Provide a succinct answer. -1.44. In the year 2006, what is the difference between the Expenditure(as % of GDP) in Latin America(all income levels) and Expenditure(as % of GDP) in Iran?
Provide a succinct answer. -0.01. In the year 2006, what is the difference between the Expenditure(as % of GDP) in France and Expenditure(as % of GDP) in Iran?
Keep it short and to the point. 1.43. In the year 2008, what is the difference between the Expenditure(as % of GDP) in Europe(developing only) and Expenditure(as % of GDP) in Latin America(all income levels)?
Provide a short and direct response. -0.08. In the year 2008, what is the difference between the Expenditure(as % of GDP) of Europe(developing only) and Expenditure(as % of GDP) of France?
Offer a very short reply. -1.45. In the year 2008, what is the difference between the Expenditure(as % of GDP) of Europe(developing only) and Expenditure(as % of GDP) of Iran?
Ensure brevity in your answer.  -0.14. In the year 2008, what is the difference between the Expenditure(as % of GDP) of Latin America(all income levels) and Expenditure(as % of GDP) of France?
Your answer should be very brief. -1.36. In the year 2008, what is the difference between the Expenditure(as % of GDP) in Latin America(all income levels) and Expenditure(as % of GDP) in Iran?
Offer a very short reply. -0.06. In the year 2008, what is the difference between the Expenditure(as % of GDP) of France and Expenditure(as % of GDP) of Iran?
Provide a short and direct response. 1.31. What is the ratio of the Expenditure(as % of GDP) of France in 2001 to that in 2002?
Offer a very short reply. 0.98. What is the ratio of the Expenditure(as % of GDP) of Europe(developing only) in 2001 to that in 2003?
Your answer should be compact. 1.06. What is the ratio of the Expenditure(as % of GDP) of Latin America(all income levels) in 2001 to that in 2003?
Your answer should be compact. 0.96. What is the ratio of the Expenditure(as % of GDP) of France in 2001 to that in 2003?
Ensure brevity in your answer.  1.01. What is the ratio of the Expenditure(as % of GDP) in Iran in 2001 to that in 2003?
Provide a succinct answer. 0.82. What is the ratio of the Expenditure(as % of GDP) in Europe(developing only) in 2001 to that in 2004?
Your response must be concise. 1.04. What is the ratio of the Expenditure(as % of GDP) of Latin America(all income levels) in 2001 to that in 2004?
Provide a short and direct response. 0.95. What is the ratio of the Expenditure(as % of GDP) of France in 2001 to that in 2004?
Keep it short and to the point. 1.02. What is the ratio of the Expenditure(as % of GDP) of Iran in 2001 to that in 2004?
Give a very brief answer. 0.94. What is the ratio of the Expenditure(as % of GDP) of Europe(developing only) in 2001 to that in 2005?
Your response must be concise. 0.93. What is the ratio of the Expenditure(as % of GDP) in Latin America(all income levels) in 2001 to that in 2005?
Your answer should be compact. 0.88. What is the ratio of the Expenditure(as % of GDP) in France in 2001 to that in 2005?
Make the answer very short. 1.04. What is the ratio of the Expenditure(as % of GDP) in Iran in 2001 to that in 2005?
Your answer should be compact. 0.75. What is the ratio of the Expenditure(as % of GDP) of Europe(developing only) in 2001 to that in 2006?
Give a very brief answer. 0.97. What is the ratio of the Expenditure(as % of GDP) in Latin America(all income levels) in 2001 to that in 2006?
Offer a very short reply. 0.89. What is the ratio of the Expenditure(as % of GDP) in France in 2001 to that in 2006?
Provide a short and direct response. 1.04. What is the ratio of the Expenditure(as % of GDP) of Iran in 2001 to that in 2006?
Give a very brief answer. 0.9. What is the ratio of the Expenditure(as % of GDP) in Europe(developing only) in 2001 to that in 2008?
Provide a succinct answer. 0.87. What is the ratio of the Expenditure(as % of GDP) in Latin America(all income levels) in 2001 to that in 2008?
Provide a short and direct response. 0.78. What is the ratio of the Expenditure(as % of GDP) in France in 2001 to that in 2008?
Keep it short and to the point. 1.03. What is the ratio of the Expenditure(as % of GDP) in Iran in 2001 to that in 2008?
Your answer should be compact. 0.74. What is the ratio of the Expenditure(as % of GDP) of Europe(developing only) in 2002 to that in 2003?
Ensure brevity in your answer.  1.06. What is the ratio of the Expenditure(as % of GDP) in Latin America(all income levels) in 2002 to that in 2003?
Keep it short and to the point. 0.94. What is the ratio of the Expenditure(as % of GDP) of France in 2002 to that in 2003?
Provide a short and direct response. 1.03. What is the ratio of the Expenditure(as % of GDP) in Iran in 2002 to that in 2003?
Your response must be concise. 0.81. What is the ratio of the Expenditure(as % of GDP) in Europe(developing only) in 2002 to that in 2004?
Make the answer very short. 1.04. What is the ratio of the Expenditure(as % of GDP) in Latin America(all income levels) in 2002 to that in 2004?
Your answer should be very brief. 0.94. What is the ratio of the Expenditure(as % of GDP) in France in 2002 to that in 2004?
Ensure brevity in your answer.  1.04. What is the ratio of the Expenditure(as % of GDP) of Iran in 2002 to that in 2004?
Make the answer very short. 0.93. What is the ratio of the Expenditure(as % of GDP) in Europe(developing only) in 2002 to that in 2005?
Your answer should be very brief. 0.93. What is the ratio of the Expenditure(as % of GDP) of Latin America(all income levels) in 2002 to that in 2005?
Your answer should be very brief. 0.86. What is the ratio of the Expenditure(as % of GDP) of France in 2002 to that in 2005?
Give a very brief answer. 1.06. What is the ratio of the Expenditure(as % of GDP) of Iran in 2002 to that in 2005?
Your answer should be compact. 0.75. What is the ratio of the Expenditure(as % of GDP) in Europe(developing only) in 2002 to that in 2006?
Ensure brevity in your answer.  0.97. What is the ratio of the Expenditure(as % of GDP) in Latin America(all income levels) in 2002 to that in 2006?
Keep it short and to the point. 0.88. What is the ratio of the Expenditure(as % of GDP) in France in 2002 to that in 2006?
Your answer should be very brief. 1.06. What is the ratio of the Expenditure(as % of GDP) in Iran in 2002 to that in 2006?
Make the answer very short. 0.89. What is the ratio of the Expenditure(as % of GDP) in Europe(developing only) in 2002 to that in 2008?
Your answer should be very brief. 0.87. What is the ratio of the Expenditure(as % of GDP) in Latin America(all income levels) in 2002 to that in 2008?
Offer a very short reply. 0.77. What is the ratio of the Expenditure(as % of GDP) in France in 2002 to that in 2008?
Provide a short and direct response. 1.05. What is the ratio of the Expenditure(as % of GDP) in Iran in 2002 to that in 2008?
Keep it short and to the point. 0.73. What is the ratio of the Expenditure(as % of GDP) in Europe(developing only) in 2003 to that in 2004?
Your answer should be very brief. 0.98. What is the ratio of the Expenditure(as % of GDP) in France in 2003 to that in 2004?
Your answer should be compact. 1.01. What is the ratio of the Expenditure(as % of GDP) of Iran in 2003 to that in 2004?
Make the answer very short. 1.15. What is the ratio of the Expenditure(as % of GDP) of Europe(developing only) in 2003 to that in 2005?
Keep it short and to the point. 0.88. What is the ratio of the Expenditure(as % of GDP) in Latin America(all income levels) in 2003 to that in 2005?
Ensure brevity in your answer.  0.91. What is the ratio of the Expenditure(as % of GDP) of France in 2003 to that in 2005?
Your answer should be compact. 1.03. What is the ratio of the Expenditure(as % of GDP) of Iran in 2003 to that in 2005?
Make the answer very short. 0.92. What is the ratio of the Expenditure(as % of GDP) in Europe(developing only) in 2003 to that in 2006?
Make the answer very short. 0.92. What is the ratio of the Expenditure(as % of GDP) in Latin America(all income levels) in 2003 to that in 2006?
Your answer should be compact. 0.93. What is the ratio of the Expenditure(as % of GDP) of France in 2003 to that in 2006?
Offer a terse response. 1.03. What is the ratio of the Expenditure(as % of GDP) in Iran in 2003 to that in 2006?
Your response must be concise. 1.1. What is the ratio of the Expenditure(as % of GDP) of Europe(developing only) in 2003 to that in 2008?
Ensure brevity in your answer.  0.83. What is the ratio of the Expenditure(as % of GDP) of Latin America(all income levels) in 2003 to that in 2008?
Provide a short and direct response. 0.81. What is the ratio of the Expenditure(as % of GDP) of France in 2003 to that in 2008?
Provide a succinct answer. 1.03. What is the ratio of the Expenditure(as % of GDP) of Iran in 2003 to that in 2008?
Provide a succinct answer. 0.9. What is the ratio of the Expenditure(as % of GDP) of Europe(developing only) in 2004 to that in 2005?
Keep it short and to the point. 0.89. What is the ratio of the Expenditure(as % of GDP) of Latin America(all income levels) in 2004 to that in 2005?
Give a very brief answer. 0.92. What is the ratio of the Expenditure(as % of GDP) of France in 2004 to that in 2005?
Offer a very short reply. 1.02. What is the ratio of the Expenditure(as % of GDP) of Iran in 2004 to that in 2005?
Keep it short and to the point. 0.8. What is the ratio of the Expenditure(as % of GDP) in Europe(developing only) in 2004 to that in 2006?
Offer a very short reply. 0.94. What is the ratio of the Expenditure(as % of GDP) in Latin America(all income levels) in 2004 to that in 2006?
Offer a terse response. 0.94. What is the ratio of the Expenditure(as % of GDP) of France in 2004 to that in 2006?
Give a very brief answer. 1.02. What is the ratio of the Expenditure(as % of GDP) in Iran in 2004 to that in 2006?
Your answer should be very brief. 0.96. What is the ratio of the Expenditure(as % of GDP) of Europe(developing only) in 2004 to that in 2008?
Your answer should be compact. 0.84. What is the ratio of the Expenditure(as % of GDP) of Latin America(all income levels) in 2004 to that in 2008?
Offer a terse response. 0.82. What is the ratio of the Expenditure(as % of GDP) in Iran in 2004 to that in 2008?
Offer a very short reply. 0.78. What is the ratio of the Expenditure(as % of GDP) of Europe(developing only) in 2005 to that in 2006?
Your answer should be compact. 1.05. What is the ratio of the Expenditure(as % of GDP) of Latin America(all income levels) in 2005 to that in 2006?
Your response must be concise. 1.02. What is the ratio of the Expenditure(as % of GDP) of Iran in 2005 to that in 2006?
Ensure brevity in your answer.  1.2. What is the ratio of the Expenditure(as % of GDP) of Europe(developing only) in 2005 to that in 2008?
Your response must be concise. 0.94. What is the ratio of the Expenditure(as % of GDP) of Latin America(all income levels) in 2005 to that in 2008?
Offer a very short reply. 0.89. What is the ratio of the Expenditure(as % of GDP) of France in 2005 to that in 2008?
Keep it short and to the point. 0.99. What is the ratio of the Expenditure(as % of GDP) of Europe(developing only) in 2006 to that in 2008?
Provide a succinct answer. 0.9. What is the ratio of the Expenditure(as % of GDP) of Latin America(all income levels) in 2006 to that in 2008?
Your answer should be compact. 0.88. What is the ratio of the Expenditure(as % of GDP) in France in 2006 to that in 2008?
Your answer should be very brief. 0.99. What is the ratio of the Expenditure(as % of GDP) in Iran in 2006 to that in 2008?
Provide a succinct answer. 0.82. What is the difference between the highest and the second highest Expenditure(as % of GDP) of Europe(developing only)?
Your answer should be very brief. 0.03. What is the difference between the highest and the second highest Expenditure(as % of GDP) in Latin America(all income levels)?
Offer a very short reply. 0.07. What is the difference between the highest and the second highest Expenditure(as % of GDP) in France?
Give a very brief answer. 0.04. What is the difference between the highest and the second highest Expenditure(as % of GDP) in Iran?
Provide a short and direct response. 0.01. What is the difference between the highest and the lowest Expenditure(as % of GDP) in Europe(developing only)?
Make the answer very short. 0.11. What is the difference between the highest and the lowest Expenditure(as % of GDP) in Latin America(all income levels)?
Provide a short and direct response. 0.16. What is the difference between the highest and the lowest Expenditure(as % of GDP) in France?
Give a very brief answer. 0.12. What is the difference between the highest and the lowest Expenditure(as % of GDP) of Iran?
Make the answer very short. 0.2. 